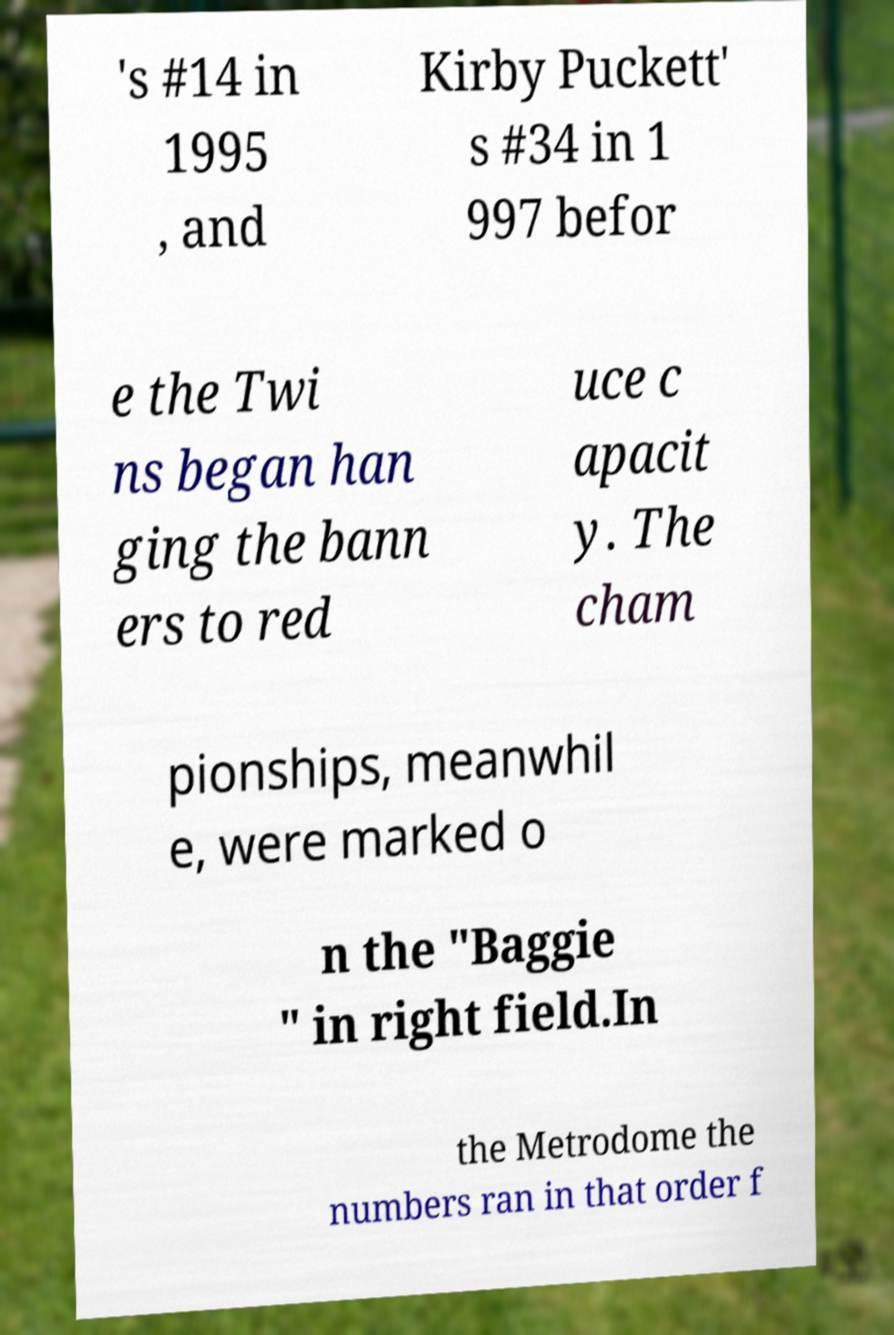I need the written content from this picture converted into text. Can you do that? 's #14 in 1995 , and Kirby Puckett' s #34 in 1 997 befor e the Twi ns began han ging the bann ers to red uce c apacit y. The cham pionships, meanwhil e, were marked o n the "Baggie " in right field.In the Metrodome the numbers ran in that order f 